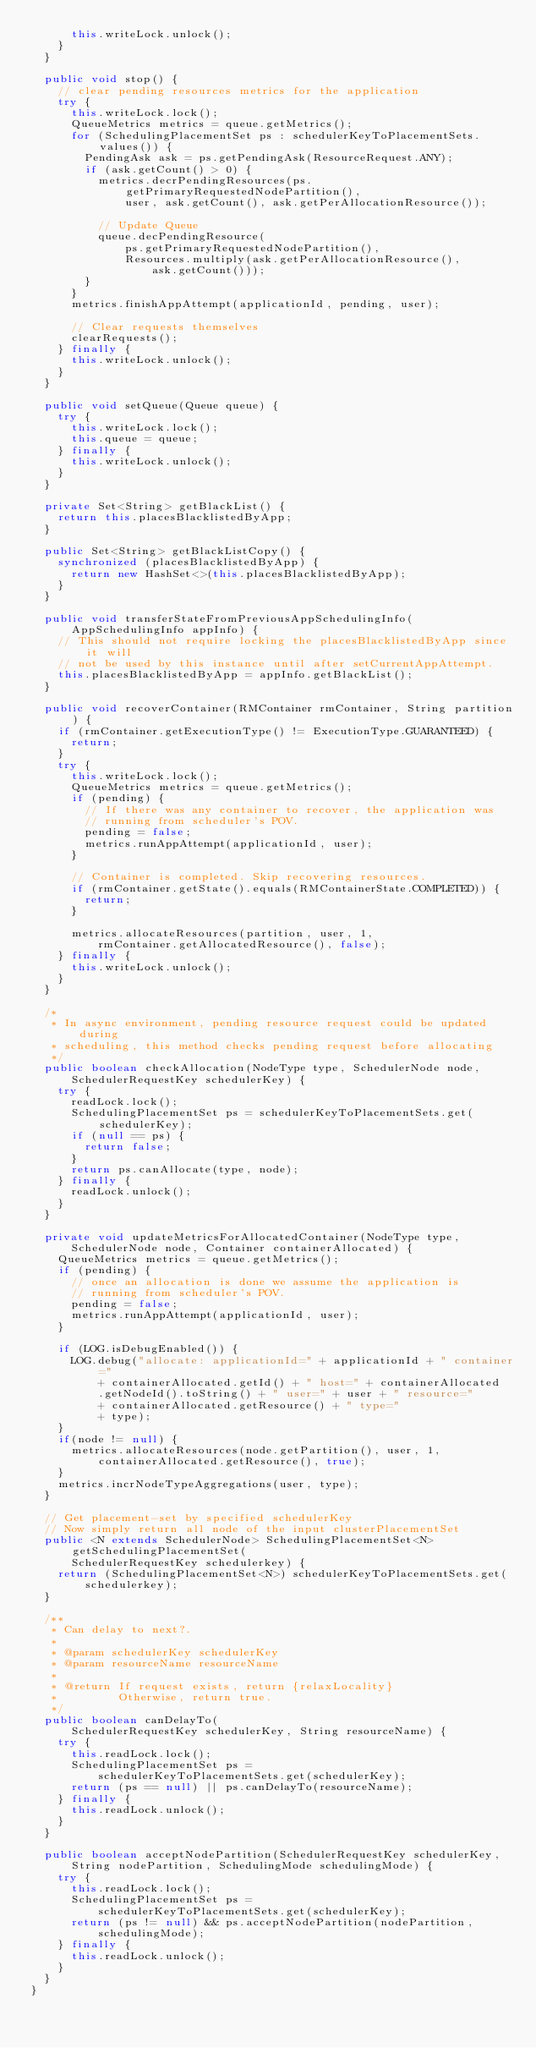<code> <loc_0><loc_0><loc_500><loc_500><_Java_>      this.writeLock.unlock();
    }
  }

  public void stop() {
    // clear pending resources metrics for the application
    try {
      this.writeLock.lock();
      QueueMetrics metrics = queue.getMetrics();
      for (SchedulingPlacementSet ps : schedulerKeyToPlacementSets.values()) {
        PendingAsk ask = ps.getPendingAsk(ResourceRequest.ANY);
        if (ask.getCount() > 0) {
          metrics.decrPendingResources(ps.getPrimaryRequestedNodePartition(),
              user, ask.getCount(), ask.getPerAllocationResource());

          // Update Queue
          queue.decPendingResource(
              ps.getPrimaryRequestedNodePartition(),
              Resources.multiply(ask.getPerAllocationResource(),
                  ask.getCount()));
        }
      }
      metrics.finishAppAttempt(applicationId, pending, user);

      // Clear requests themselves
      clearRequests();
    } finally {
      this.writeLock.unlock();
    }
  }

  public void setQueue(Queue queue) {
    try {
      this.writeLock.lock();
      this.queue = queue;
    } finally {
      this.writeLock.unlock();
    }
  }

  private Set<String> getBlackList() {
    return this.placesBlacklistedByApp;
  }

  public Set<String> getBlackListCopy() {
    synchronized (placesBlacklistedByApp) {
      return new HashSet<>(this.placesBlacklistedByApp);
    }
  }

  public void transferStateFromPreviousAppSchedulingInfo(
      AppSchedulingInfo appInfo) {
    // This should not require locking the placesBlacklistedByApp since it will
    // not be used by this instance until after setCurrentAppAttempt.
    this.placesBlacklistedByApp = appInfo.getBlackList();
  }

  public void recoverContainer(RMContainer rmContainer, String partition) {
    if (rmContainer.getExecutionType() != ExecutionType.GUARANTEED) {
      return;
    }
    try {
      this.writeLock.lock();
      QueueMetrics metrics = queue.getMetrics();
      if (pending) {
        // If there was any container to recover, the application was
        // running from scheduler's POV.
        pending = false;
        metrics.runAppAttempt(applicationId, user);
      }

      // Container is completed. Skip recovering resources.
      if (rmContainer.getState().equals(RMContainerState.COMPLETED)) {
        return;
      }

      metrics.allocateResources(partition, user, 1,
          rmContainer.getAllocatedResource(), false);
    } finally {
      this.writeLock.unlock();
    }
  }

  /*
   * In async environment, pending resource request could be updated during
   * scheduling, this method checks pending request before allocating
   */
  public boolean checkAllocation(NodeType type, SchedulerNode node,
      SchedulerRequestKey schedulerKey) {
    try {
      readLock.lock();
      SchedulingPlacementSet ps = schedulerKeyToPlacementSets.get(schedulerKey);
      if (null == ps) {
        return false;
      }
      return ps.canAllocate(type, node);
    } finally {
      readLock.unlock();
    }
  }

  private void updateMetricsForAllocatedContainer(NodeType type,
      SchedulerNode node, Container containerAllocated) {
    QueueMetrics metrics = queue.getMetrics();
    if (pending) {
      // once an allocation is done we assume the application is
      // running from scheduler's POV.
      pending = false;
      metrics.runAppAttempt(applicationId, user);
    }

    if (LOG.isDebugEnabled()) {
      LOG.debug("allocate: applicationId=" + applicationId + " container="
          + containerAllocated.getId() + " host=" + containerAllocated
          .getNodeId().toString() + " user=" + user + " resource="
          + containerAllocated.getResource() + " type="
          + type);
    }
    if(node != null) {
      metrics.allocateResources(node.getPartition(), user, 1,
          containerAllocated.getResource(), true);
    }
    metrics.incrNodeTypeAggregations(user, type);
  }

  // Get placement-set by specified schedulerKey
  // Now simply return all node of the input clusterPlacementSet
  public <N extends SchedulerNode> SchedulingPlacementSet<N> getSchedulingPlacementSet(
      SchedulerRequestKey schedulerkey) {
    return (SchedulingPlacementSet<N>) schedulerKeyToPlacementSets.get(
        schedulerkey);
  }

  /**
   * Can delay to next?.
   *
   * @param schedulerKey schedulerKey
   * @param resourceName resourceName
   *
   * @return If request exists, return {relaxLocality}
   *         Otherwise, return true.
   */
  public boolean canDelayTo(
      SchedulerRequestKey schedulerKey, String resourceName) {
    try {
      this.readLock.lock();
      SchedulingPlacementSet ps =
          schedulerKeyToPlacementSets.get(schedulerKey);
      return (ps == null) || ps.canDelayTo(resourceName);
    } finally {
      this.readLock.unlock();
    }
  }

  public boolean acceptNodePartition(SchedulerRequestKey schedulerKey,
      String nodePartition, SchedulingMode schedulingMode) {
    try {
      this.readLock.lock();
      SchedulingPlacementSet ps =
          schedulerKeyToPlacementSets.get(schedulerKey);
      return (ps != null) && ps.acceptNodePartition(nodePartition,
          schedulingMode);
    } finally {
      this.readLock.unlock();
    }
  }
}
</code> 